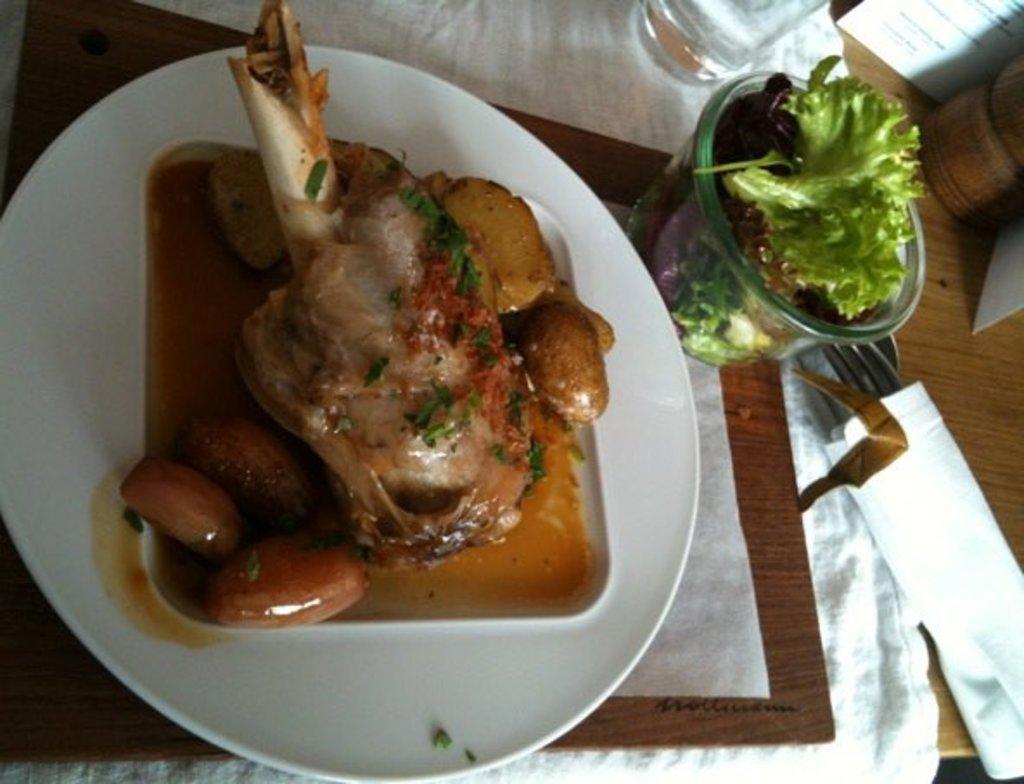In one or two sentences, can you explain what this image depicts? In this image, we can see some eatable things and food items on the plate and bowl. Here we can see tissues, spoon and fork. Top of the image, we can see few objects. Here we can see a wooden surface. 